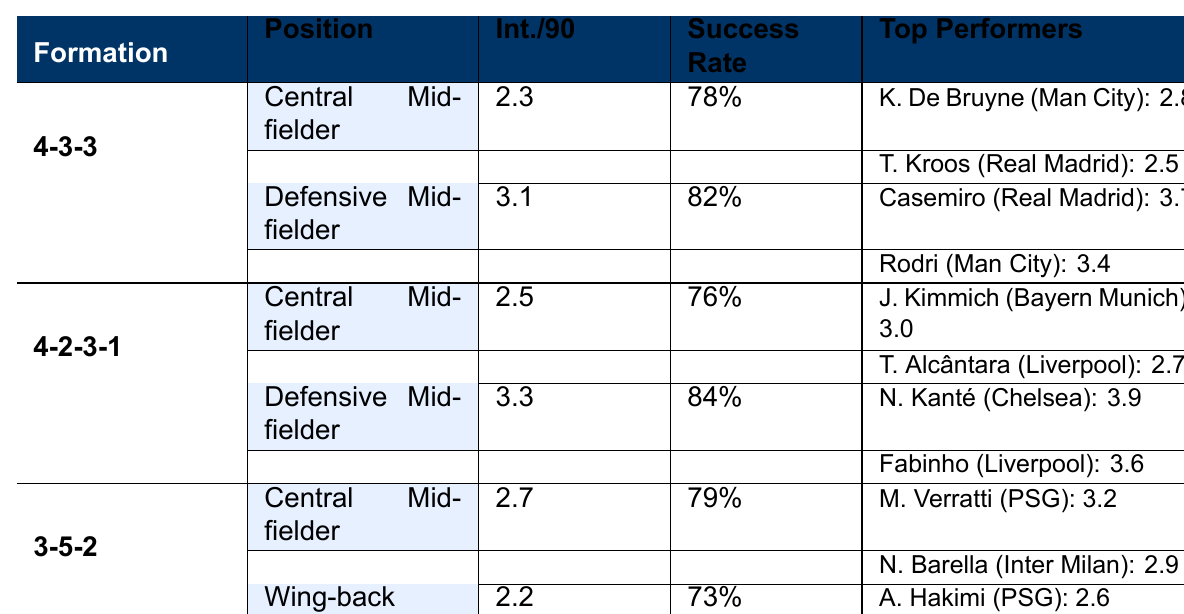What is the success rate of the Defensive Midfielder in the 4-2-3-1 formation? Referring to the table, the success rate for the Defensive Midfielder in the 4-2-3-1 formation is 84%.
Answer: 84% Which player has the most interceptions per 90 minutes in the 4-3-3 formation? In the 4-3-3 formation, the Defensive Midfielder Casemiro has the highest interceptions per 90 minutes with 3.7.
Answer: Casemiro What is the average interceptions per 90 minutes for Central Midfielders across all formations? The interceptions per 90 minutes for Central Midfielders are 2.3 (4-3-3), 2.5 (4-2-3-1), and 2.7 (3-5-2). The average is (2.3 + 2.5 + 2.7) / 3 = 2.5.
Answer: 2.5 Is the success rate of Wing-backs higher than that of Central Midfielders in the 3-5-2 formation? The success rate of Wing-backs is 73% and for Central Midfielders, it is 79%. Since 79% is greater than 73%, the statement is false.
Answer: No How many total players have an interceptions per 90 minutes greater than 3 in the table? In the table, players with more than 3 interceptions per 90 minutes are Casemiro (3.7), Rodri (3.4), N'Golo Kanté (3.9), and Fabinho (3.6). That's a total of 4 players.
Answer: 4 What is the difference in interceptions per 90 minutes between the highest and lowest performing Defensive Midfielder? The highest performing Defensive Midfielder is N'Golo Kanté with 3.9 interceptions per 90 minutes, and the lowest is Casemiro with 3.7 interceptions. The difference is 3.9 - 3.1 = 0.8.
Answer: 0.8 Which formation has the highest average interceptions per 90 minutes for Central Midfielders? The average interceptions per 90 minutes for Central Midfielders are 2.3 (4-3-3), 2.5 (4-2-3-1), and 2.7 (3-5-2). The highest is 2.7 for the 3-5-2 formation.
Answer: 3-5-2 Does the player Joshua Kimmich have a higher success rate than Kevin De Bruyne? Joshua Kimmich has a success rate of 76%, while Kevin De Bruyne has a success rate of 78%. Since 76% is lower than 78%, the statement is false.
Answer: No 